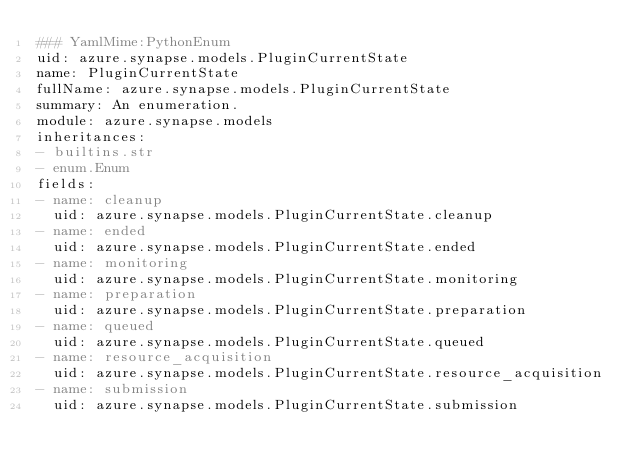<code> <loc_0><loc_0><loc_500><loc_500><_YAML_>### YamlMime:PythonEnum
uid: azure.synapse.models.PluginCurrentState
name: PluginCurrentState
fullName: azure.synapse.models.PluginCurrentState
summary: An enumeration.
module: azure.synapse.models
inheritances:
- builtins.str
- enum.Enum
fields:
- name: cleanup
  uid: azure.synapse.models.PluginCurrentState.cleanup
- name: ended
  uid: azure.synapse.models.PluginCurrentState.ended
- name: monitoring
  uid: azure.synapse.models.PluginCurrentState.monitoring
- name: preparation
  uid: azure.synapse.models.PluginCurrentState.preparation
- name: queued
  uid: azure.synapse.models.PluginCurrentState.queued
- name: resource_acquisition
  uid: azure.synapse.models.PluginCurrentState.resource_acquisition
- name: submission
  uid: azure.synapse.models.PluginCurrentState.submission
</code> 